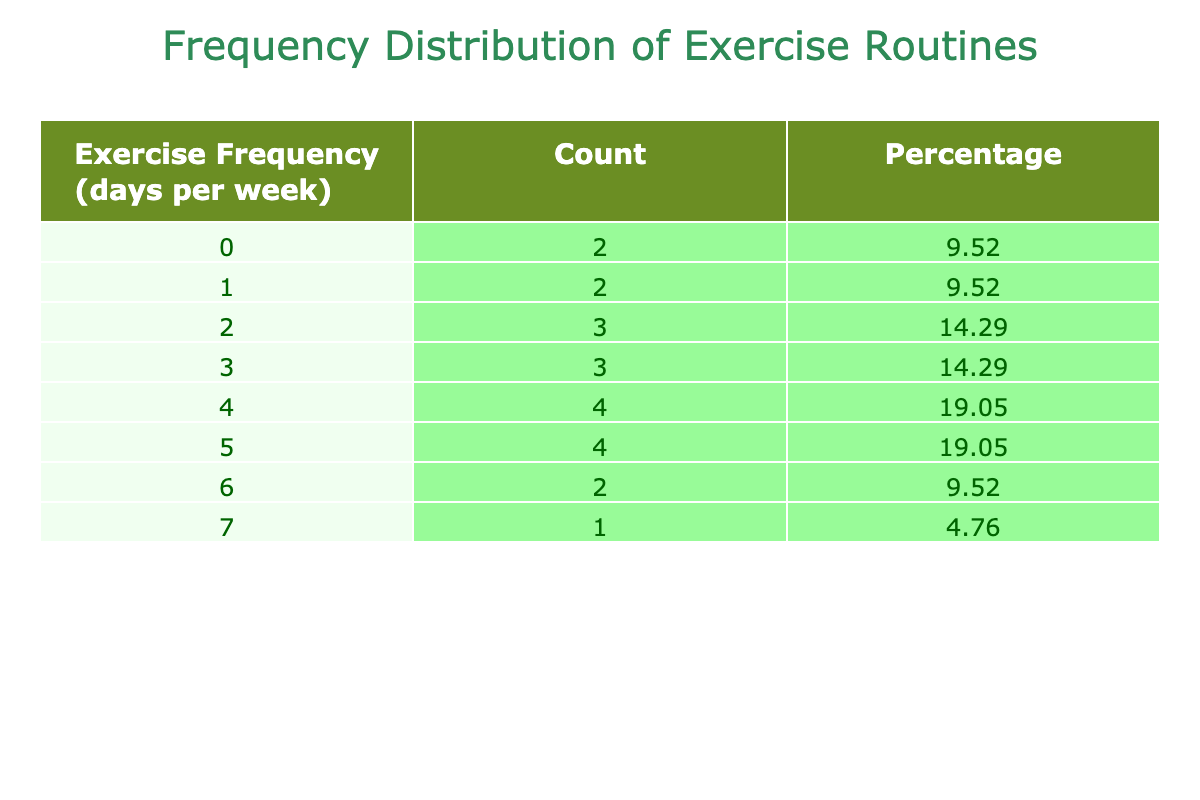What is the maximum frequency of exercise routines followed by the clients? The maximum value in the 'Exercise Frequency' column of the table is 7, which corresponds to the client Katie Wilson.
Answer: 7 How many clients exercise 4 times a week? By referencing the 'Count' column for the 'Exercise Frequency' of 4, we see that there are 4 clients who reported this frequency.
Answer: 4 What percentage of clients exercise at least 5 times a week? Clients who exercise 5 or more times a week are those who reported 5 (5 clients) and 6 (2 clients) and 7 (1 client). The total count of these clients is 8. Thus, the percentage is (8/20)*100 = 40%.
Answer: 40% Is there any client that does not exercise at all? Checking the 'Exercise Frequency' column, we see that there is one client, James Johnson, who has a frequency of 0, clearly indicating he does not exercise.
Answer: Yes What is the average frequency of exercise routines among all clients? To find the average, we sum all the exercise frequencies: (5 + 3 + 4 + 6 + 2 + 4 + 5 + 1 + 3 + 0 + 7 + 4 + 2 + 5 + 1 + 3 + 2 + 6 + 4 + 5) = 60. Then, we divide by the total number of clients, which is 20. Therefore, 60/20 = 3.
Answer: 3 Which exercise frequency is the least popular? Looking at the 'Count' column, we see that the least count corresponds to the frequency of 0, indicating one client exercises not at all, followed by the frequency of 1, which has 2 clients participating.
Answer: 0 How many clients exercise less than 3 times a week? To find this, we need to consider the frequencies of 0, 1, and 2. There is 1 client who exercises 0 times, 2 clients who exercise 1 time, and 3 clients who exercise 2 times. Adding these counts gives 1+2+3 = 6 clients.
Answer: 6 What is the difference between the number of clients exercising 3 times a week and those exercising 6 times a week? The table shows that 4 clients reported exercising 3 times a week while 2 clients reported exercising 6 times a week. Therefore, the difference is 4 - 2 = 2.
Answer: 2 How many clients exercise 2 or fewer times a week? The frequencies that meet this criterion are 0, 1, and 2. By checking the count for these frequencies: 1 for 0, 2 for 1, and 3 for 2, we add them up: 1+2+3 = 6 clients total.
Answer: 6 